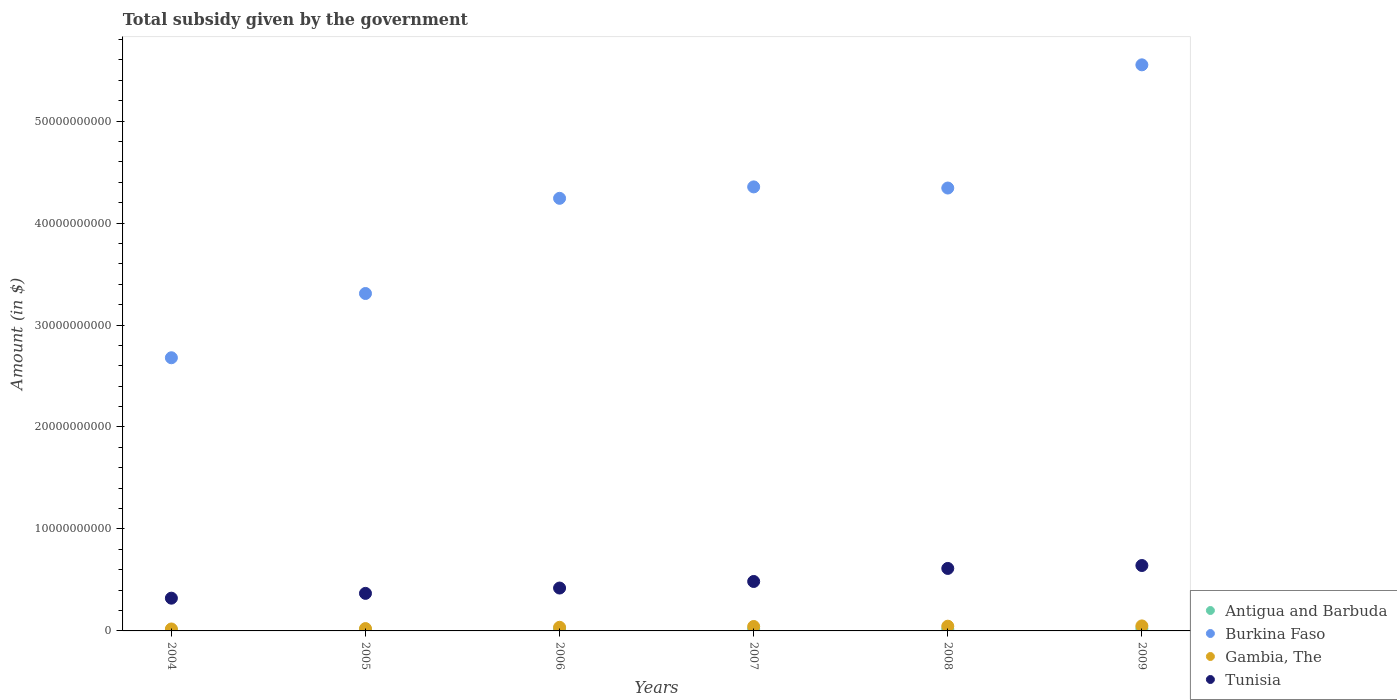How many different coloured dotlines are there?
Ensure brevity in your answer.  4. Is the number of dotlines equal to the number of legend labels?
Keep it short and to the point. Yes. What is the total revenue collected by the government in Gambia, The in 2004?
Make the answer very short. 1.91e+08. Across all years, what is the maximum total revenue collected by the government in Gambia, The?
Make the answer very short. 4.90e+08. Across all years, what is the minimum total revenue collected by the government in Gambia, The?
Keep it short and to the point. 1.91e+08. In which year was the total revenue collected by the government in Antigua and Barbuda maximum?
Your answer should be compact. 2009. In which year was the total revenue collected by the government in Gambia, The minimum?
Give a very brief answer. 2004. What is the total total revenue collected by the government in Antigua and Barbuda in the graph?
Offer a terse response. 9.76e+08. What is the difference between the total revenue collected by the government in Burkina Faso in 2008 and that in 2009?
Your response must be concise. -1.21e+1. What is the difference between the total revenue collected by the government in Tunisia in 2006 and the total revenue collected by the government in Antigua and Barbuda in 2004?
Offer a terse response. 4.12e+09. What is the average total revenue collected by the government in Tunisia per year?
Keep it short and to the point. 4.75e+09. In the year 2009, what is the difference between the total revenue collected by the government in Burkina Faso and total revenue collected by the government in Gambia, The?
Your answer should be compact. 5.50e+1. What is the ratio of the total revenue collected by the government in Gambia, The in 2007 to that in 2009?
Ensure brevity in your answer.  0.89. Is the total revenue collected by the government in Antigua and Barbuda in 2005 less than that in 2007?
Ensure brevity in your answer.  Yes. What is the difference between the highest and the second highest total revenue collected by the government in Antigua and Barbuda?
Provide a succinct answer. 3.28e+07. What is the difference between the highest and the lowest total revenue collected by the government in Antigua and Barbuda?
Offer a very short reply. 1.42e+08. Is it the case that in every year, the sum of the total revenue collected by the government in Antigua and Barbuda and total revenue collected by the government in Burkina Faso  is greater than the sum of total revenue collected by the government in Tunisia and total revenue collected by the government in Gambia, The?
Ensure brevity in your answer.  Yes. Does the total revenue collected by the government in Tunisia monotonically increase over the years?
Provide a short and direct response. Yes. Is the total revenue collected by the government in Burkina Faso strictly greater than the total revenue collected by the government in Antigua and Barbuda over the years?
Keep it short and to the point. Yes. Is the total revenue collected by the government in Tunisia strictly less than the total revenue collected by the government in Burkina Faso over the years?
Provide a succinct answer. Yes. How many years are there in the graph?
Your response must be concise. 6. Are the values on the major ticks of Y-axis written in scientific E-notation?
Your response must be concise. No. Does the graph contain any zero values?
Provide a short and direct response. No. Does the graph contain grids?
Keep it short and to the point. No. How are the legend labels stacked?
Provide a succinct answer. Vertical. What is the title of the graph?
Your answer should be compact. Total subsidy given by the government. What is the label or title of the Y-axis?
Your answer should be compact. Amount (in $). What is the Amount (in $) of Antigua and Barbuda in 2004?
Your answer should be very brief. 8.29e+07. What is the Amount (in $) in Burkina Faso in 2004?
Provide a short and direct response. 2.68e+1. What is the Amount (in $) in Gambia, The in 2004?
Ensure brevity in your answer.  1.91e+08. What is the Amount (in $) of Tunisia in 2004?
Keep it short and to the point. 3.21e+09. What is the Amount (in $) in Antigua and Barbuda in 2005?
Provide a succinct answer. 1.10e+08. What is the Amount (in $) in Burkina Faso in 2005?
Provide a succinct answer. 3.31e+1. What is the Amount (in $) of Gambia, The in 2005?
Your answer should be compact. 2.31e+08. What is the Amount (in $) in Tunisia in 2005?
Offer a terse response. 3.68e+09. What is the Amount (in $) of Antigua and Barbuda in 2006?
Give a very brief answer. 1.92e+08. What is the Amount (in $) of Burkina Faso in 2006?
Offer a terse response. 4.24e+1. What is the Amount (in $) in Gambia, The in 2006?
Your response must be concise. 3.56e+08. What is the Amount (in $) in Tunisia in 2006?
Ensure brevity in your answer.  4.20e+09. What is the Amount (in $) in Antigua and Barbuda in 2007?
Your answer should be compact. 1.88e+08. What is the Amount (in $) in Burkina Faso in 2007?
Provide a succinct answer. 4.35e+1. What is the Amount (in $) in Gambia, The in 2007?
Keep it short and to the point. 4.34e+08. What is the Amount (in $) of Tunisia in 2007?
Offer a terse response. 4.85e+09. What is the Amount (in $) in Antigua and Barbuda in 2008?
Give a very brief answer. 1.78e+08. What is the Amount (in $) in Burkina Faso in 2008?
Provide a succinct answer. 4.34e+1. What is the Amount (in $) of Gambia, The in 2008?
Make the answer very short. 4.63e+08. What is the Amount (in $) in Tunisia in 2008?
Provide a short and direct response. 6.13e+09. What is the Amount (in $) in Antigua and Barbuda in 2009?
Keep it short and to the point. 2.24e+08. What is the Amount (in $) of Burkina Faso in 2009?
Your answer should be compact. 5.55e+1. What is the Amount (in $) of Gambia, The in 2009?
Your answer should be very brief. 4.90e+08. What is the Amount (in $) of Tunisia in 2009?
Make the answer very short. 6.41e+09. Across all years, what is the maximum Amount (in $) of Antigua and Barbuda?
Your answer should be very brief. 2.24e+08. Across all years, what is the maximum Amount (in $) of Burkina Faso?
Make the answer very short. 5.55e+1. Across all years, what is the maximum Amount (in $) in Gambia, The?
Ensure brevity in your answer.  4.90e+08. Across all years, what is the maximum Amount (in $) of Tunisia?
Offer a terse response. 6.41e+09. Across all years, what is the minimum Amount (in $) in Antigua and Barbuda?
Your answer should be very brief. 8.29e+07. Across all years, what is the minimum Amount (in $) in Burkina Faso?
Offer a very short reply. 2.68e+1. Across all years, what is the minimum Amount (in $) of Gambia, The?
Your answer should be very brief. 1.91e+08. Across all years, what is the minimum Amount (in $) of Tunisia?
Provide a short and direct response. 3.21e+09. What is the total Amount (in $) in Antigua and Barbuda in the graph?
Your answer should be very brief. 9.76e+08. What is the total Amount (in $) in Burkina Faso in the graph?
Offer a very short reply. 2.45e+11. What is the total Amount (in $) in Gambia, The in the graph?
Your answer should be very brief. 2.17e+09. What is the total Amount (in $) in Tunisia in the graph?
Ensure brevity in your answer.  2.85e+1. What is the difference between the Amount (in $) of Antigua and Barbuda in 2004 and that in 2005?
Keep it short and to the point. -2.73e+07. What is the difference between the Amount (in $) in Burkina Faso in 2004 and that in 2005?
Provide a succinct answer. -6.30e+09. What is the difference between the Amount (in $) in Gambia, The in 2004 and that in 2005?
Your answer should be very brief. -3.98e+07. What is the difference between the Amount (in $) in Tunisia in 2004 and that in 2005?
Provide a short and direct response. -4.71e+08. What is the difference between the Amount (in $) of Antigua and Barbuda in 2004 and that in 2006?
Your answer should be very brief. -1.09e+08. What is the difference between the Amount (in $) of Burkina Faso in 2004 and that in 2006?
Make the answer very short. -1.56e+1. What is the difference between the Amount (in $) in Gambia, The in 2004 and that in 2006?
Your answer should be compact. -1.65e+08. What is the difference between the Amount (in $) of Tunisia in 2004 and that in 2006?
Make the answer very short. -9.93e+08. What is the difference between the Amount (in $) of Antigua and Barbuda in 2004 and that in 2007?
Your answer should be compact. -1.06e+08. What is the difference between the Amount (in $) of Burkina Faso in 2004 and that in 2007?
Give a very brief answer. -1.68e+1. What is the difference between the Amount (in $) in Gambia, The in 2004 and that in 2007?
Ensure brevity in your answer.  -2.44e+08. What is the difference between the Amount (in $) in Tunisia in 2004 and that in 2007?
Your response must be concise. -1.64e+09. What is the difference between the Amount (in $) of Antigua and Barbuda in 2004 and that in 2008?
Offer a very short reply. -9.55e+07. What is the difference between the Amount (in $) in Burkina Faso in 2004 and that in 2008?
Provide a short and direct response. -1.66e+1. What is the difference between the Amount (in $) in Gambia, The in 2004 and that in 2008?
Give a very brief answer. -2.72e+08. What is the difference between the Amount (in $) in Tunisia in 2004 and that in 2008?
Provide a short and direct response. -2.92e+09. What is the difference between the Amount (in $) of Antigua and Barbuda in 2004 and that in 2009?
Your response must be concise. -1.42e+08. What is the difference between the Amount (in $) in Burkina Faso in 2004 and that in 2009?
Offer a terse response. -2.87e+1. What is the difference between the Amount (in $) of Gambia, The in 2004 and that in 2009?
Provide a succinct answer. -3.00e+08. What is the difference between the Amount (in $) in Tunisia in 2004 and that in 2009?
Provide a succinct answer. -3.20e+09. What is the difference between the Amount (in $) in Antigua and Barbuda in 2005 and that in 2006?
Keep it short and to the point. -8.14e+07. What is the difference between the Amount (in $) in Burkina Faso in 2005 and that in 2006?
Offer a very short reply. -9.33e+09. What is the difference between the Amount (in $) of Gambia, The in 2005 and that in 2006?
Give a very brief answer. -1.26e+08. What is the difference between the Amount (in $) of Tunisia in 2005 and that in 2006?
Give a very brief answer. -5.22e+08. What is the difference between the Amount (in $) in Antigua and Barbuda in 2005 and that in 2007?
Give a very brief answer. -7.83e+07. What is the difference between the Amount (in $) of Burkina Faso in 2005 and that in 2007?
Offer a very short reply. -1.05e+1. What is the difference between the Amount (in $) in Gambia, The in 2005 and that in 2007?
Offer a very short reply. -2.04e+08. What is the difference between the Amount (in $) in Tunisia in 2005 and that in 2007?
Make the answer very short. -1.17e+09. What is the difference between the Amount (in $) in Antigua and Barbuda in 2005 and that in 2008?
Your response must be concise. -6.82e+07. What is the difference between the Amount (in $) of Burkina Faso in 2005 and that in 2008?
Your answer should be very brief. -1.03e+1. What is the difference between the Amount (in $) of Gambia, The in 2005 and that in 2008?
Provide a short and direct response. -2.33e+08. What is the difference between the Amount (in $) of Tunisia in 2005 and that in 2008?
Provide a succinct answer. -2.45e+09. What is the difference between the Amount (in $) of Antigua and Barbuda in 2005 and that in 2009?
Your answer should be very brief. -1.14e+08. What is the difference between the Amount (in $) in Burkina Faso in 2005 and that in 2009?
Your answer should be compact. -2.24e+1. What is the difference between the Amount (in $) in Gambia, The in 2005 and that in 2009?
Offer a very short reply. -2.60e+08. What is the difference between the Amount (in $) in Tunisia in 2005 and that in 2009?
Give a very brief answer. -2.73e+09. What is the difference between the Amount (in $) in Antigua and Barbuda in 2006 and that in 2007?
Make the answer very short. 3.10e+06. What is the difference between the Amount (in $) of Burkina Faso in 2006 and that in 2007?
Give a very brief answer. -1.12e+09. What is the difference between the Amount (in $) in Gambia, The in 2006 and that in 2007?
Your answer should be very brief. -7.82e+07. What is the difference between the Amount (in $) in Tunisia in 2006 and that in 2007?
Give a very brief answer. -6.44e+08. What is the difference between the Amount (in $) in Antigua and Barbuda in 2006 and that in 2008?
Keep it short and to the point. 1.32e+07. What is the difference between the Amount (in $) of Burkina Faso in 2006 and that in 2008?
Offer a terse response. -1.01e+09. What is the difference between the Amount (in $) in Gambia, The in 2006 and that in 2008?
Your answer should be compact. -1.07e+08. What is the difference between the Amount (in $) in Tunisia in 2006 and that in 2008?
Provide a short and direct response. -1.92e+09. What is the difference between the Amount (in $) of Antigua and Barbuda in 2006 and that in 2009?
Your answer should be very brief. -3.28e+07. What is the difference between the Amount (in $) in Burkina Faso in 2006 and that in 2009?
Your answer should be compact. -1.31e+1. What is the difference between the Amount (in $) in Gambia, The in 2006 and that in 2009?
Make the answer very short. -1.34e+08. What is the difference between the Amount (in $) of Tunisia in 2006 and that in 2009?
Offer a terse response. -2.21e+09. What is the difference between the Amount (in $) in Antigua and Barbuda in 2007 and that in 2008?
Keep it short and to the point. 1.01e+07. What is the difference between the Amount (in $) of Burkina Faso in 2007 and that in 2008?
Keep it short and to the point. 1.12e+08. What is the difference between the Amount (in $) in Gambia, The in 2007 and that in 2008?
Ensure brevity in your answer.  -2.89e+07. What is the difference between the Amount (in $) in Tunisia in 2007 and that in 2008?
Offer a very short reply. -1.28e+09. What is the difference between the Amount (in $) of Antigua and Barbuda in 2007 and that in 2009?
Provide a short and direct response. -3.59e+07. What is the difference between the Amount (in $) of Burkina Faso in 2007 and that in 2009?
Give a very brief answer. -1.20e+1. What is the difference between the Amount (in $) of Gambia, The in 2007 and that in 2009?
Keep it short and to the point. -5.60e+07. What is the difference between the Amount (in $) in Tunisia in 2007 and that in 2009?
Ensure brevity in your answer.  -1.57e+09. What is the difference between the Amount (in $) in Antigua and Barbuda in 2008 and that in 2009?
Offer a terse response. -4.60e+07. What is the difference between the Amount (in $) of Burkina Faso in 2008 and that in 2009?
Your answer should be very brief. -1.21e+1. What is the difference between the Amount (in $) in Gambia, The in 2008 and that in 2009?
Keep it short and to the point. -2.71e+07. What is the difference between the Amount (in $) of Tunisia in 2008 and that in 2009?
Give a very brief answer. -2.86e+08. What is the difference between the Amount (in $) of Antigua and Barbuda in 2004 and the Amount (in $) of Burkina Faso in 2005?
Ensure brevity in your answer.  -3.30e+1. What is the difference between the Amount (in $) of Antigua and Barbuda in 2004 and the Amount (in $) of Gambia, The in 2005?
Offer a terse response. -1.48e+08. What is the difference between the Amount (in $) in Antigua and Barbuda in 2004 and the Amount (in $) in Tunisia in 2005?
Give a very brief answer. -3.60e+09. What is the difference between the Amount (in $) of Burkina Faso in 2004 and the Amount (in $) of Gambia, The in 2005?
Your answer should be compact. 2.66e+1. What is the difference between the Amount (in $) in Burkina Faso in 2004 and the Amount (in $) in Tunisia in 2005?
Your response must be concise. 2.31e+1. What is the difference between the Amount (in $) of Gambia, The in 2004 and the Amount (in $) of Tunisia in 2005?
Offer a terse response. -3.49e+09. What is the difference between the Amount (in $) of Antigua and Barbuda in 2004 and the Amount (in $) of Burkina Faso in 2006?
Offer a very short reply. -4.23e+1. What is the difference between the Amount (in $) of Antigua and Barbuda in 2004 and the Amount (in $) of Gambia, The in 2006?
Your answer should be compact. -2.73e+08. What is the difference between the Amount (in $) of Antigua and Barbuda in 2004 and the Amount (in $) of Tunisia in 2006?
Offer a terse response. -4.12e+09. What is the difference between the Amount (in $) in Burkina Faso in 2004 and the Amount (in $) in Gambia, The in 2006?
Keep it short and to the point. 2.64e+1. What is the difference between the Amount (in $) in Burkina Faso in 2004 and the Amount (in $) in Tunisia in 2006?
Ensure brevity in your answer.  2.26e+1. What is the difference between the Amount (in $) in Gambia, The in 2004 and the Amount (in $) in Tunisia in 2006?
Your answer should be compact. -4.01e+09. What is the difference between the Amount (in $) of Antigua and Barbuda in 2004 and the Amount (in $) of Burkina Faso in 2007?
Your response must be concise. -4.35e+1. What is the difference between the Amount (in $) in Antigua and Barbuda in 2004 and the Amount (in $) in Gambia, The in 2007?
Your answer should be compact. -3.51e+08. What is the difference between the Amount (in $) of Antigua and Barbuda in 2004 and the Amount (in $) of Tunisia in 2007?
Ensure brevity in your answer.  -4.77e+09. What is the difference between the Amount (in $) in Burkina Faso in 2004 and the Amount (in $) in Gambia, The in 2007?
Make the answer very short. 2.64e+1. What is the difference between the Amount (in $) in Burkina Faso in 2004 and the Amount (in $) in Tunisia in 2007?
Ensure brevity in your answer.  2.19e+1. What is the difference between the Amount (in $) of Gambia, The in 2004 and the Amount (in $) of Tunisia in 2007?
Your answer should be compact. -4.66e+09. What is the difference between the Amount (in $) of Antigua and Barbuda in 2004 and the Amount (in $) of Burkina Faso in 2008?
Your response must be concise. -4.33e+1. What is the difference between the Amount (in $) in Antigua and Barbuda in 2004 and the Amount (in $) in Gambia, The in 2008?
Your response must be concise. -3.80e+08. What is the difference between the Amount (in $) of Antigua and Barbuda in 2004 and the Amount (in $) of Tunisia in 2008?
Your answer should be compact. -6.04e+09. What is the difference between the Amount (in $) in Burkina Faso in 2004 and the Amount (in $) in Gambia, The in 2008?
Your answer should be compact. 2.63e+1. What is the difference between the Amount (in $) in Burkina Faso in 2004 and the Amount (in $) in Tunisia in 2008?
Your answer should be compact. 2.07e+1. What is the difference between the Amount (in $) of Gambia, The in 2004 and the Amount (in $) of Tunisia in 2008?
Make the answer very short. -5.94e+09. What is the difference between the Amount (in $) in Antigua and Barbuda in 2004 and the Amount (in $) in Burkina Faso in 2009?
Give a very brief answer. -5.54e+1. What is the difference between the Amount (in $) of Antigua and Barbuda in 2004 and the Amount (in $) of Gambia, The in 2009?
Keep it short and to the point. -4.07e+08. What is the difference between the Amount (in $) in Antigua and Barbuda in 2004 and the Amount (in $) in Tunisia in 2009?
Make the answer very short. -6.33e+09. What is the difference between the Amount (in $) in Burkina Faso in 2004 and the Amount (in $) in Gambia, The in 2009?
Make the answer very short. 2.63e+1. What is the difference between the Amount (in $) of Burkina Faso in 2004 and the Amount (in $) of Tunisia in 2009?
Offer a terse response. 2.04e+1. What is the difference between the Amount (in $) of Gambia, The in 2004 and the Amount (in $) of Tunisia in 2009?
Your answer should be compact. -6.22e+09. What is the difference between the Amount (in $) in Antigua and Barbuda in 2005 and the Amount (in $) in Burkina Faso in 2006?
Offer a terse response. -4.23e+1. What is the difference between the Amount (in $) of Antigua and Barbuda in 2005 and the Amount (in $) of Gambia, The in 2006?
Your response must be concise. -2.46e+08. What is the difference between the Amount (in $) in Antigua and Barbuda in 2005 and the Amount (in $) in Tunisia in 2006?
Your response must be concise. -4.09e+09. What is the difference between the Amount (in $) of Burkina Faso in 2005 and the Amount (in $) of Gambia, The in 2006?
Your answer should be compact. 3.27e+1. What is the difference between the Amount (in $) in Burkina Faso in 2005 and the Amount (in $) in Tunisia in 2006?
Keep it short and to the point. 2.89e+1. What is the difference between the Amount (in $) in Gambia, The in 2005 and the Amount (in $) in Tunisia in 2006?
Your response must be concise. -3.97e+09. What is the difference between the Amount (in $) of Antigua and Barbuda in 2005 and the Amount (in $) of Burkina Faso in 2007?
Offer a very short reply. -4.34e+1. What is the difference between the Amount (in $) of Antigua and Barbuda in 2005 and the Amount (in $) of Gambia, The in 2007?
Your answer should be compact. -3.24e+08. What is the difference between the Amount (in $) of Antigua and Barbuda in 2005 and the Amount (in $) of Tunisia in 2007?
Your answer should be very brief. -4.74e+09. What is the difference between the Amount (in $) in Burkina Faso in 2005 and the Amount (in $) in Gambia, The in 2007?
Your answer should be compact. 3.27e+1. What is the difference between the Amount (in $) of Burkina Faso in 2005 and the Amount (in $) of Tunisia in 2007?
Ensure brevity in your answer.  2.82e+1. What is the difference between the Amount (in $) of Gambia, The in 2005 and the Amount (in $) of Tunisia in 2007?
Give a very brief answer. -4.62e+09. What is the difference between the Amount (in $) in Antigua and Barbuda in 2005 and the Amount (in $) in Burkina Faso in 2008?
Offer a terse response. -4.33e+1. What is the difference between the Amount (in $) of Antigua and Barbuda in 2005 and the Amount (in $) of Gambia, The in 2008?
Your response must be concise. -3.53e+08. What is the difference between the Amount (in $) in Antigua and Barbuda in 2005 and the Amount (in $) in Tunisia in 2008?
Your response must be concise. -6.02e+09. What is the difference between the Amount (in $) in Burkina Faso in 2005 and the Amount (in $) in Gambia, The in 2008?
Provide a short and direct response. 3.26e+1. What is the difference between the Amount (in $) of Burkina Faso in 2005 and the Amount (in $) of Tunisia in 2008?
Make the answer very short. 2.70e+1. What is the difference between the Amount (in $) in Gambia, The in 2005 and the Amount (in $) in Tunisia in 2008?
Provide a succinct answer. -5.90e+09. What is the difference between the Amount (in $) of Antigua and Barbuda in 2005 and the Amount (in $) of Burkina Faso in 2009?
Give a very brief answer. -5.54e+1. What is the difference between the Amount (in $) in Antigua and Barbuda in 2005 and the Amount (in $) in Gambia, The in 2009?
Offer a very short reply. -3.80e+08. What is the difference between the Amount (in $) in Antigua and Barbuda in 2005 and the Amount (in $) in Tunisia in 2009?
Give a very brief answer. -6.30e+09. What is the difference between the Amount (in $) of Burkina Faso in 2005 and the Amount (in $) of Gambia, The in 2009?
Make the answer very short. 3.26e+1. What is the difference between the Amount (in $) in Burkina Faso in 2005 and the Amount (in $) in Tunisia in 2009?
Provide a short and direct response. 2.67e+1. What is the difference between the Amount (in $) in Gambia, The in 2005 and the Amount (in $) in Tunisia in 2009?
Your answer should be very brief. -6.18e+09. What is the difference between the Amount (in $) in Antigua and Barbuda in 2006 and the Amount (in $) in Burkina Faso in 2007?
Give a very brief answer. -4.34e+1. What is the difference between the Amount (in $) of Antigua and Barbuda in 2006 and the Amount (in $) of Gambia, The in 2007?
Keep it short and to the point. -2.43e+08. What is the difference between the Amount (in $) in Antigua and Barbuda in 2006 and the Amount (in $) in Tunisia in 2007?
Make the answer very short. -4.66e+09. What is the difference between the Amount (in $) in Burkina Faso in 2006 and the Amount (in $) in Gambia, The in 2007?
Provide a succinct answer. 4.20e+1. What is the difference between the Amount (in $) of Burkina Faso in 2006 and the Amount (in $) of Tunisia in 2007?
Your answer should be very brief. 3.76e+1. What is the difference between the Amount (in $) in Gambia, The in 2006 and the Amount (in $) in Tunisia in 2007?
Your answer should be very brief. -4.49e+09. What is the difference between the Amount (in $) in Antigua and Barbuda in 2006 and the Amount (in $) in Burkina Faso in 2008?
Your answer should be very brief. -4.32e+1. What is the difference between the Amount (in $) in Antigua and Barbuda in 2006 and the Amount (in $) in Gambia, The in 2008?
Your answer should be very brief. -2.72e+08. What is the difference between the Amount (in $) of Antigua and Barbuda in 2006 and the Amount (in $) of Tunisia in 2008?
Give a very brief answer. -5.94e+09. What is the difference between the Amount (in $) in Burkina Faso in 2006 and the Amount (in $) in Gambia, The in 2008?
Your answer should be compact. 4.20e+1. What is the difference between the Amount (in $) in Burkina Faso in 2006 and the Amount (in $) in Tunisia in 2008?
Give a very brief answer. 3.63e+1. What is the difference between the Amount (in $) of Gambia, The in 2006 and the Amount (in $) of Tunisia in 2008?
Provide a short and direct response. -5.77e+09. What is the difference between the Amount (in $) of Antigua and Barbuda in 2006 and the Amount (in $) of Burkina Faso in 2009?
Offer a very short reply. -5.53e+1. What is the difference between the Amount (in $) in Antigua and Barbuda in 2006 and the Amount (in $) in Gambia, The in 2009?
Your response must be concise. -2.99e+08. What is the difference between the Amount (in $) in Antigua and Barbuda in 2006 and the Amount (in $) in Tunisia in 2009?
Provide a short and direct response. -6.22e+09. What is the difference between the Amount (in $) in Burkina Faso in 2006 and the Amount (in $) in Gambia, The in 2009?
Provide a succinct answer. 4.19e+1. What is the difference between the Amount (in $) in Burkina Faso in 2006 and the Amount (in $) in Tunisia in 2009?
Offer a very short reply. 3.60e+1. What is the difference between the Amount (in $) in Gambia, The in 2006 and the Amount (in $) in Tunisia in 2009?
Provide a succinct answer. -6.06e+09. What is the difference between the Amount (in $) of Antigua and Barbuda in 2007 and the Amount (in $) of Burkina Faso in 2008?
Your answer should be very brief. -4.32e+1. What is the difference between the Amount (in $) of Antigua and Barbuda in 2007 and the Amount (in $) of Gambia, The in 2008?
Offer a terse response. -2.75e+08. What is the difference between the Amount (in $) in Antigua and Barbuda in 2007 and the Amount (in $) in Tunisia in 2008?
Your answer should be compact. -5.94e+09. What is the difference between the Amount (in $) of Burkina Faso in 2007 and the Amount (in $) of Gambia, The in 2008?
Keep it short and to the point. 4.31e+1. What is the difference between the Amount (in $) in Burkina Faso in 2007 and the Amount (in $) in Tunisia in 2008?
Keep it short and to the point. 3.74e+1. What is the difference between the Amount (in $) in Gambia, The in 2007 and the Amount (in $) in Tunisia in 2008?
Give a very brief answer. -5.69e+09. What is the difference between the Amount (in $) in Antigua and Barbuda in 2007 and the Amount (in $) in Burkina Faso in 2009?
Make the answer very short. -5.53e+1. What is the difference between the Amount (in $) of Antigua and Barbuda in 2007 and the Amount (in $) of Gambia, The in 2009?
Provide a succinct answer. -3.02e+08. What is the difference between the Amount (in $) in Antigua and Barbuda in 2007 and the Amount (in $) in Tunisia in 2009?
Give a very brief answer. -6.23e+09. What is the difference between the Amount (in $) of Burkina Faso in 2007 and the Amount (in $) of Gambia, The in 2009?
Your answer should be very brief. 4.31e+1. What is the difference between the Amount (in $) in Burkina Faso in 2007 and the Amount (in $) in Tunisia in 2009?
Offer a terse response. 3.71e+1. What is the difference between the Amount (in $) in Gambia, The in 2007 and the Amount (in $) in Tunisia in 2009?
Make the answer very short. -5.98e+09. What is the difference between the Amount (in $) of Antigua and Barbuda in 2008 and the Amount (in $) of Burkina Faso in 2009?
Offer a terse response. -5.53e+1. What is the difference between the Amount (in $) in Antigua and Barbuda in 2008 and the Amount (in $) in Gambia, The in 2009?
Offer a very short reply. -3.12e+08. What is the difference between the Amount (in $) in Antigua and Barbuda in 2008 and the Amount (in $) in Tunisia in 2009?
Offer a very short reply. -6.24e+09. What is the difference between the Amount (in $) of Burkina Faso in 2008 and the Amount (in $) of Gambia, The in 2009?
Offer a terse response. 4.29e+1. What is the difference between the Amount (in $) of Burkina Faso in 2008 and the Amount (in $) of Tunisia in 2009?
Ensure brevity in your answer.  3.70e+1. What is the difference between the Amount (in $) of Gambia, The in 2008 and the Amount (in $) of Tunisia in 2009?
Provide a succinct answer. -5.95e+09. What is the average Amount (in $) in Antigua and Barbuda per year?
Your response must be concise. 1.63e+08. What is the average Amount (in $) of Burkina Faso per year?
Provide a short and direct response. 4.08e+1. What is the average Amount (in $) in Gambia, The per year?
Offer a terse response. 3.61e+08. What is the average Amount (in $) of Tunisia per year?
Your answer should be compact. 4.75e+09. In the year 2004, what is the difference between the Amount (in $) in Antigua and Barbuda and Amount (in $) in Burkina Faso?
Provide a succinct answer. -2.67e+1. In the year 2004, what is the difference between the Amount (in $) in Antigua and Barbuda and Amount (in $) in Gambia, The?
Ensure brevity in your answer.  -1.08e+08. In the year 2004, what is the difference between the Amount (in $) in Antigua and Barbuda and Amount (in $) in Tunisia?
Keep it short and to the point. -3.13e+09. In the year 2004, what is the difference between the Amount (in $) of Burkina Faso and Amount (in $) of Gambia, The?
Keep it short and to the point. 2.66e+1. In the year 2004, what is the difference between the Amount (in $) of Burkina Faso and Amount (in $) of Tunisia?
Provide a short and direct response. 2.36e+1. In the year 2004, what is the difference between the Amount (in $) of Gambia, The and Amount (in $) of Tunisia?
Keep it short and to the point. -3.02e+09. In the year 2005, what is the difference between the Amount (in $) in Antigua and Barbuda and Amount (in $) in Burkina Faso?
Keep it short and to the point. -3.30e+1. In the year 2005, what is the difference between the Amount (in $) in Antigua and Barbuda and Amount (in $) in Gambia, The?
Your answer should be very brief. -1.20e+08. In the year 2005, what is the difference between the Amount (in $) in Antigua and Barbuda and Amount (in $) in Tunisia?
Provide a short and direct response. -3.57e+09. In the year 2005, what is the difference between the Amount (in $) in Burkina Faso and Amount (in $) in Gambia, The?
Offer a terse response. 3.29e+1. In the year 2005, what is the difference between the Amount (in $) of Burkina Faso and Amount (in $) of Tunisia?
Your answer should be compact. 2.94e+1. In the year 2005, what is the difference between the Amount (in $) in Gambia, The and Amount (in $) in Tunisia?
Your response must be concise. -3.45e+09. In the year 2006, what is the difference between the Amount (in $) of Antigua and Barbuda and Amount (in $) of Burkina Faso?
Ensure brevity in your answer.  -4.22e+1. In the year 2006, what is the difference between the Amount (in $) of Antigua and Barbuda and Amount (in $) of Gambia, The?
Give a very brief answer. -1.64e+08. In the year 2006, what is the difference between the Amount (in $) of Antigua and Barbuda and Amount (in $) of Tunisia?
Provide a succinct answer. -4.01e+09. In the year 2006, what is the difference between the Amount (in $) of Burkina Faso and Amount (in $) of Gambia, The?
Offer a terse response. 4.21e+1. In the year 2006, what is the difference between the Amount (in $) in Burkina Faso and Amount (in $) in Tunisia?
Offer a very short reply. 3.82e+1. In the year 2006, what is the difference between the Amount (in $) of Gambia, The and Amount (in $) of Tunisia?
Offer a terse response. -3.85e+09. In the year 2007, what is the difference between the Amount (in $) of Antigua and Barbuda and Amount (in $) of Burkina Faso?
Make the answer very short. -4.34e+1. In the year 2007, what is the difference between the Amount (in $) in Antigua and Barbuda and Amount (in $) in Gambia, The?
Offer a terse response. -2.46e+08. In the year 2007, what is the difference between the Amount (in $) in Antigua and Barbuda and Amount (in $) in Tunisia?
Offer a terse response. -4.66e+09. In the year 2007, what is the difference between the Amount (in $) of Burkina Faso and Amount (in $) of Gambia, The?
Your answer should be compact. 4.31e+1. In the year 2007, what is the difference between the Amount (in $) in Burkina Faso and Amount (in $) in Tunisia?
Offer a terse response. 3.87e+1. In the year 2007, what is the difference between the Amount (in $) in Gambia, The and Amount (in $) in Tunisia?
Ensure brevity in your answer.  -4.41e+09. In the year 2008, what is the difference between the Amount (in $) of Antigua and Barbuda and Amount (in $) of Burkina Faso?
Make the answer very short. -4.33e+1. In the year 2008, what is the difference between the Amount (in $) of Antigua and Barbuda and Amount (in $) of Gambia, The?
Give a very brief answer. -2.85e+08. In the year 2008, what is the difference between the Amount (in $) in Antigua and Barbuda and Amount (in $) in Tunisia?
Your answer should be compact. -5.95e+09. In the year 2008, what is the difference between the Amount (in $) of Burkina Faso and Amount (in $) of Gambia, The?
Offer a terse response. 4.30e+1. In the year 2008, what is the difference between the Amount (in $) of Burkina Faso and Amount (in $) of Tunisia?
Ensure brevity in your answer.  3.73e+1. In the year 2008, what is the difference between the Amount (in $) of Gambia, The and Amount (in $) of Tunisia?
Ensure brevity in your answer.  -5.66e+09. In the year 2009, what is the difference between the Amount (in $) in Antigua and Barbuda and Amount (in $) in Burkina Faso?
Provide a succinct answer. -5.53e+1. In the year 2009, what is the difference between the Amount (in $) in Antigua and Barbuda and Amount (in $) in Gambia, The?
Provide a short and direct response. -2.66e+08. In the year 2009, what is the difference between the Amount (in $) of Antigua and Barbuda and Amount (in $) of Tunisia?
Make the answer very short. -6.19e+09. In the year 2009, what is the difference between the Amount (in $) of Burkina Faso and Amount (in $) of Gambia, The?
Keep it short and to the point. 5.50e+1. In the year 2009, what is the difference between the Amount (in $) in Burkina Faso and Amount (in $) in Tunisia?
Make the answer very short. 4.91e+1. In the year 2009, what is the difference between the Amount (in $) in Gambia, The and Amount (in $) in Tunisia?
Make the answer very short. -5.92e+09. What is the ratio of the Amount (in $) of Antigua and Barbuda in 2004 to that in 2005?
Keep it short and to the point. 0.75. What is the ratio of the Amount (in $) in Burkina Faso in 2004 to that in 2005?
Offer a terse response. 0.81. What is the ratio of the Amount (in $) in Gambia, The in 2004 to that in 2005?
Provide a succinct answer. 0.83. What is the ratio of the Amount (in $) of Tunisia in 2004 to that in 2005?
Give a very brief answer. 0.87. What is the ratio of the Amount (in $) in Antigua and Barbuda in 2004 to that in 2006?
Your answer should be very brief. 0.43. What is the ratio of the Amount (in $) of Burkina Faso in 2004 to that in 2006?
Your response must be concise. 0.63. What is the ratio of the Amount (in $) of Gambia, The in 2004 to that in 2006?
Provide a short and direct response. 0.54. What is the ratio of the Amount (in $) of Tunisia in 2004 to that in 2006?
Offer a very short reply. 0.76. What is the ratio of the Amount (in $) in Antigua and Barbuda in 2004 to that in 2007?
Offer a very short reply. 0.44. What is the ratio of the Amount (in $) of Burkina Faso in 2004 to that in 2007?
Give a very brief answer. 0.62. What is the ratio of the Amount (in $) in Gambia, The in 2004 to that in 2007?
Make the answer very short. 0.44. What is the ratio of the Amount (in $) in Tunisia in 2004 to that in 2007?
Your response must be concise. 0.66. What is the ratio of the Amount (in $) in Antigua and Barbuda in 2004 to that in 2008?
Your answer should be very brief. 0.46. What is the ratio of the Amount (in $) in Burkina Faso in 2004 to that in 2008?
Give a very brief answer. 0.62. What is the ratio of the Amount (in $) in Gambia, The in 2004 to that in 2008?
Offer a very short reply. 0.41. What is the ratio of the Amount (in $) in Tunisia in 2004 to that in 2008?
Ensure brevity in your answer.  0.52. What is the ratio of the Amount (in $) in Antigua and Barbuda in 2004 to that in 2009?
Your answer should be very brief. 0.37. What is the ratio of the Amount (in $) in Burkina Faso in 2004 to that in 2009?
Your answer should be very brief. 0.48. What is the ratio of the Amount (in $) in Gambia, The in 2004 to that in 2009?
Keep it short and to the point. 0.39. What is the ratio of the Amount (in $) of Tunisia in 2004 to that in 2009?
Give a very brief answer. 0.5. What is the ratio of the Amount (in $) of Antigua and Barbuda in 2005 to that in 2006?
Provide a short and direct response. 0.58. What is the ratio of the Amount (in $) of Burkina Faso in 2005 to that in 2006?
Your response must be concise. 0.78. What is the ratio of the Amount (in $) in Gambia, The in 2005 to that in 2006?
Ensure brevity in your answer.  0.65. What is the ratio of the Amount (in $) in Tunisia in 2005 to that in 2006?
Offer a terse response. 0.88. What is the ratio of the Amount (in $) of Antigua and Barbuda in 2005 to that in 2007?
Provide a succinct answer. 0.58. What is the ratio of the Amount (in $) in Burkina Faso in 2005 to that in 2007?
Provide a short and direct response. 0.76. What is the ratio of the Amount (in $) of Gambia, The in 2005 to that in 2007?
Offer a very short reply. 0.53. What is the ratio of the Amount (in $) in Tunisia in 2005 to that in 2007?
Ensure brevity in your answer.  0.76. What is the ratio of the Amount (in $) in Antigua and Barbuda in 2005 to that in 2008?
Ensure brevity in your answer.  0.62. What is the ratio of the Amount (in $) of Burkina Faso in 2005 to that in 2008?
Make the answer very short. 0.76. What is the ratio of the Amount (in $) in Gambia, The in 2005 to that in 2008?
Provide a succinct answer. 0.5. What is the ratio of the Amount (in $) in Tunisia in 2005 to that in 2008?
Offer a very short reply. 0.6. What is the ratio of the Amount (in $) in Antigua and Barbuda in 2005 to that in 2009?
Make the answer very short. 0.49. What is the ratio of the Amount (in $) of Burkina Faso in 2005 to that in 2009?
Make the answer very short. 0.6. What is the ratio of the Amount (in $) of Gambia, The in 2005 to that in 2009?
Provide a short and direct response. 0.47. What is the ratio of the Amount (in $) in Tunisia in 2005 to that in 2009?
Keep it short and to the point. 0.57. What is the ratio of the Amount (in $) of Antigua and Barbuda in 2006 to that in 2007?
Your answer should be very brief. 1.02. What is the ratio of the Amount (in $) in Burkina Faso in 2006 to that in 2007?
Provide a succinct answer. 0.97. What is the ratio of the Amount (in $) of Gambia, The in 2006 to that in 2007?
Provide a succinct answer. 0.82. What is the ratio of the Amount (in $) in Tunisia in 2006 to that in 2007?
Give a very brief answer. 0.87. What is the ratio of the Amount (in $) of Antigua and Barbuda in 2006 to that in 2008?
Your answer should be compact. 1.07. What is the ratio of the Amount (in $) of Burkina Faso in 2006 to that in 2008?
Offer a terse response. 0.98. What is the ratio of the Amount (in $) of Gambia, The in 2006 to that in 2008?
Make the answer very short. 0.77. What is the ratio of the Amount (in $) in Tunisia in 2006 to that in 2008?
Provide a succinct answer. 0.69. What is the ratio of the Amount (in $) of Antigua and Barbuda in 2006 to that in 2009?
Keep it short and to the point. 0.85. What is the ratio of the Amount (in $) of Burkina Faso in 2006 to that in 2009?
Your response must be concise. 0.76. What is the ratio of the Amount (in $) in Gambia, The in 2006 to that in 2009?
Offer a terse response. 0.73. What is the ratio of the Amount (in $) of Tunisia in 2006 to that in 2009?
Your answer should be compact. 0.66. What is the ratio of the Amount (in $) of Antigua and Barbuda in 2007 to that in 2008?
Provide a succinct answer. 1.06. What is the ratio of the Amount (in $) of Gambia, The in 2007 to that in 2008?
Provide a succinct answer. 0.94. What is the ratio of the Amount (in $) of Tunisia in 2007 to that in 2008?
Ensure brevity in your answer.  0.79. What is the ratio of the Amount (in $) of Antigua and Barbuda in 2007 to that in 2009?
Your answer should be very brief. 0.84. What is the ratio of the Amount (in $) of Burkina Faso in 2007 to that in 2009?
Your response must be concise. 0.78. What is the ratio of the Amount (in $) of Gambia, The in 2007 to that in 2009?
Make the answer very short. 0.89. What is the ratio of the Amount (in $) in Tunisia in 2007 to that in 2009?
Ensure brevity in your answer.  0.76. What is the ratio of the Amount (in $) of Antigua and Barbuda in 2008 to that in 2009?
Your answer should be very brief. 0.8. What is the ratio of the Amount (in $) in Burkina Faso in 2008 to that in 2009?
Keep it short and to the point. 0.78. What is the ratio of the Amount (in $) of Gambia, The in 2008 to that in 2009?
Give a very brief answer. 0.94. What is the ratio of the Amount (in $) in Tunisia in 2008 to that in 2009?
Provide a short and direct response. 0.96. What is the difference between the highest and the second highest Amount (in $) in Antigua and Barbuda?
Ensure brevity in your answer.  3.28e+07. What is the difference between the highest and the second highest Amount (in $) of Burkina Faso?
Offer a terse response. 1.20e+1. What is the difference between the highest and the second highest Amount (in $) of Gambia, The?
Your answer should be compact. 2.71e+07. What is the difference between the highest and the second highest Amount (in $) of Tunisia?
Keep it short and to the point. 2.86e+08. What is the difference between the highest and the lowest Amount (in $) of Antigua and Barbuda?
Ensure brevity in your answer.  1.42e+08. What is the difference between the highest and the lowest Amount (in $) in Burkina Faso?
Your answer should be compact. 2.87e+1. What is the difference between the highest and the lowest Amount (in $) in Gambia, The?
Give a very brief answer. 3.00e+08. What is the difference between the highest and the lowest Amount (in $) of Tunisia?
Provide a succinct answer. 3.20e+09. 